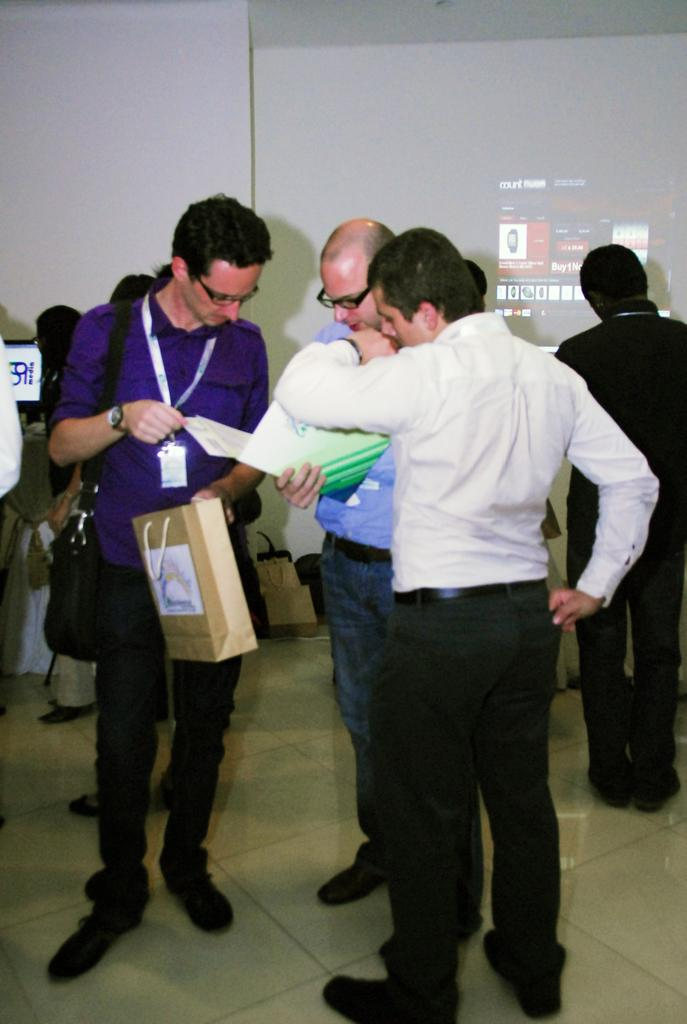What is happening in the image? There is a group of people standing in the image. Where are the people standing? The people are standing on the floor. Can you describe the man in the image? There is a man carrying a bag in the image. What can be seen in the background of the image? There are walls and a screen visible in the background of the image. Are there any other items in the background? Yes, there are bags in the background of the image. What language are the people speaking in the image? The provided facts do not mention any specific language being spoken in the image. What type of skirt is the woman wearing in the image? There is no woman wearing a skirt in the image; the group of people consists of men and women, but no specific clothing is mentioned. 